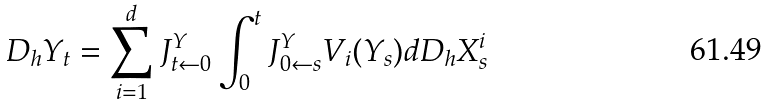Convert formula to latex. <formula><loc_0><loc_0><loc_500><loc_500>D _ { h } Y _ { t } = \sum _ { i = 1 } ^ { d } J ^ { Y } _ { t \leftarrow 0 } \int _ { 0 } ^ { t } J ^ { Y } _ { 0 \leftarrow s } V _ { i } ( Y _ { s } ) d D _ { h } X ^ { i } _ { s }</formula> 